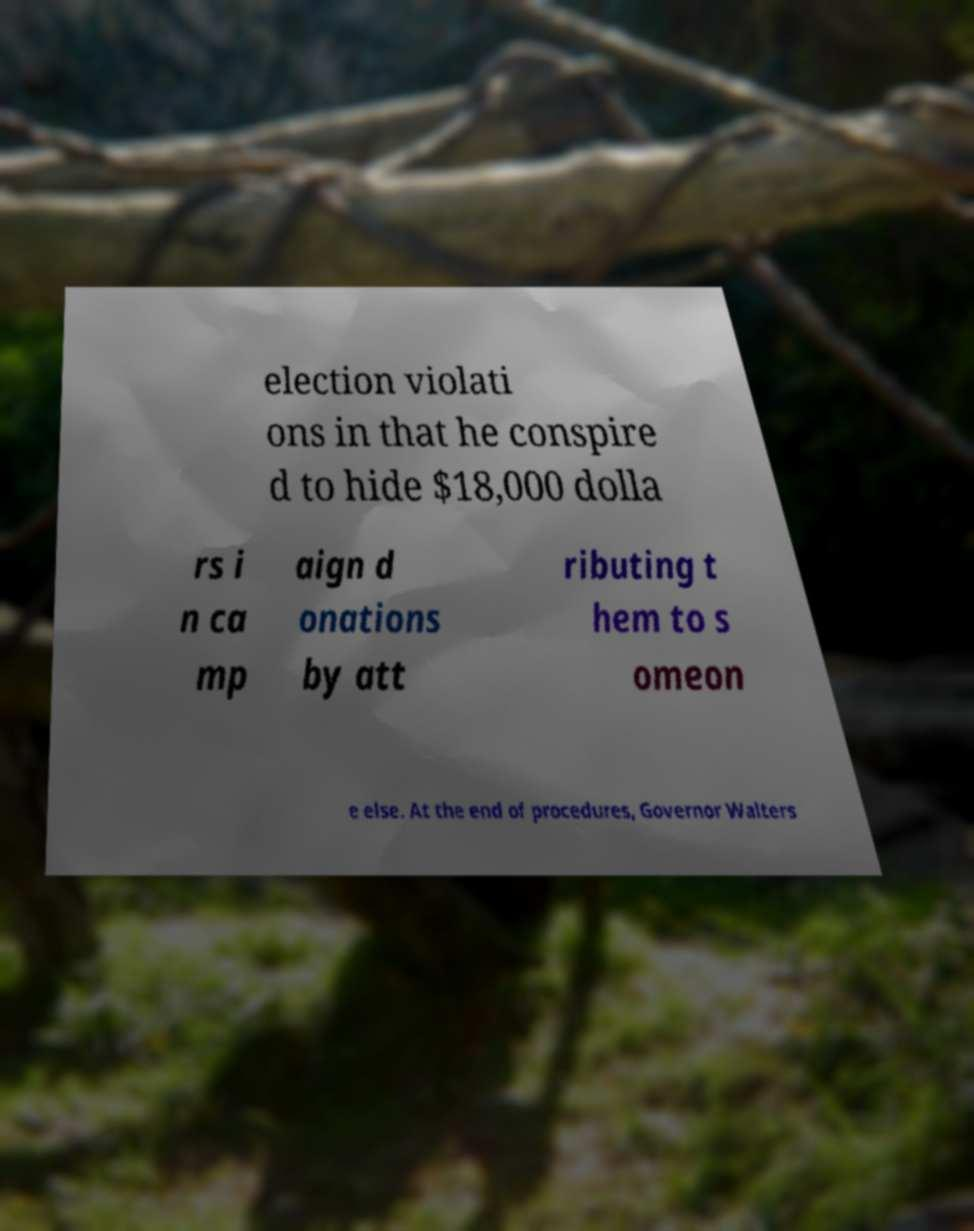I need the written content from this picture converted into text. Can you do that? election violati ons in that he conspire d to hide $18,000 dolla rs i n ca mp aign d onations by att ributing t hem to s omeon e else. At the end of procedures, Governor Walters 